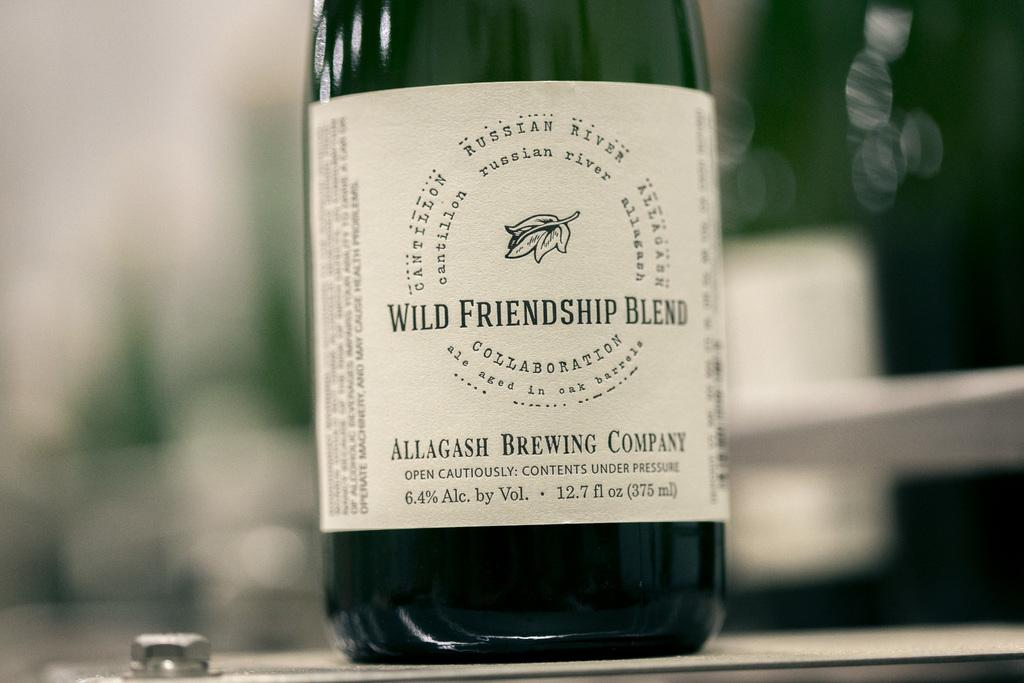<image>
Summarize the visual content of the image. the name of wind friendship blend that is on a bottle 